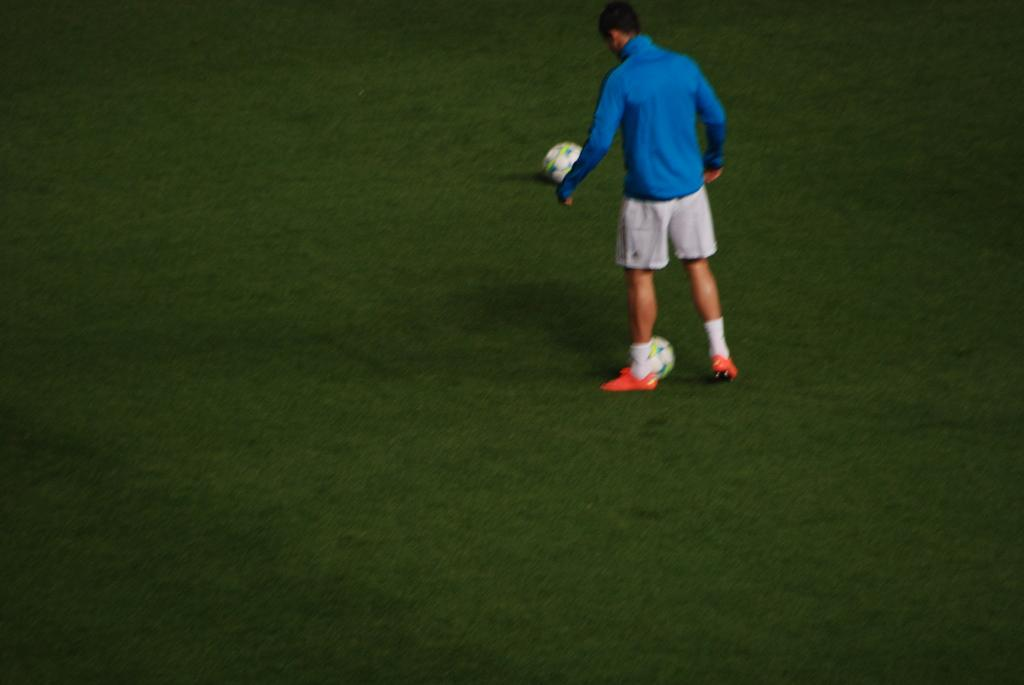What type of vegetation is present in the image? There is grass in the image. What objects can be seen in the image besides the grass? There are balls in the image. Can you describe the person in the image? There is a person wearing a blue shirt in the image. What type of whip is being used by the person in the image? There is no whip present in the image; the person is wearing a blue shirt and there are balls and grass visible. 